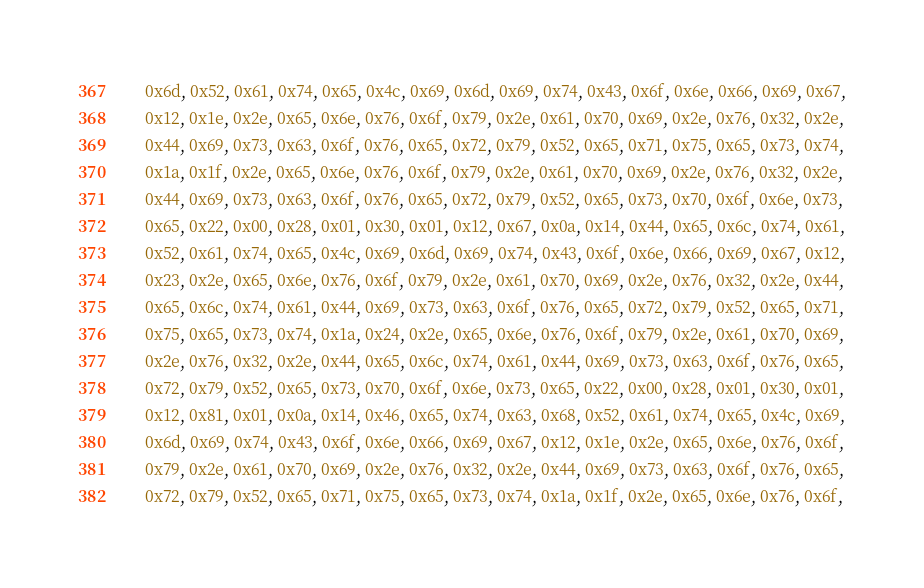Convert code to text. <code><loc_0><loc_0><loc_500><loc_500><_Go_>	0x6d, 0x52, 0x61, 0x74, 0x65, 0x4c, 0x69, 0x6d, 0x69, 0x74, 0x43, 0x6f, 0x6e, 0x66, 0x69, 0x67,
	0x12, 0x1e, 0x2e, 0x65, 0x6e, 0x76, 0x6f, 0x79, 0x2e, 0x61, 0x70, 0x69, 0x2e, 0x76, 0x32, 0x2e,
	0x44, 0x69, 0x73, 0x63, 0x6f, 0x76, 0x65, 0x72, 0x79, 0x52, 0x65, 0x71, 0x75, 0x65, 0x73, 0x74,
	0x1a, 0x1f, 0x2e, 0x65, 0x6e, 0x76, 0x6f, 0x79, 0x2e, 0x61, 0x70, 0x69, 0x2e, 0x76, 0x32, 0x2e,
	0x44, 0x69, 0x73, 0x63, 0x6f, 0x76, 0x65, 0x72, 0x79, 0x52, 0x65, 0x73, 0x70, 0x6f, 0x6e, 0x73,
	0x65, 0x22, 0x00, 0x28, 0x01, 0x30, 0x01, 0x12, 0x67, 0x0a, 0x14, 0x44, 0x65, 0x6c, 0x74, 0x61,
	0x52, 0x61, 0x74, 0x65, 0x4c, 0x69, 0x6d, 0x69, 0x74, 0x43, 0x6f, 0x6e, 0x66, 0x69, 0x67, 0x12,
	0x23, 0x2e, 0x65, 0x6e, 0x76, 0x6f, 0x79, 0x2e, 0x61, 0x70, 0x69, 0x2e, 0x76, 0x32, 0x2e, 0x44,
	0x65, 0x6c, 0x74, 0x61, 0x44, 0x69, 0x73, 0x63, 0x6f, 0x76, 0x65, 0x72, 0x79, 0x52, 0x65, 0x71,
	0x75, 0x65, 0x73, 0x74, 0x1a, 0x24, 0x2e, 0x65, 0x6e, 0x76, 0x6f, 0x79, 0x2e, 0x61, 0x70, 0x69,
	0x2e, 0x76, 0x32, 0x2e, 0x44, 0x65, 0x6c, 0x74, 0x61, 0x44, 0x69, 0x73, 0x63, 0x6f, 0x76, 0x65,
	0x72, 0x79, 0x52, 0x65, 0x73, 0x70, 0x6f, 0x6e, 0x73, 0x65, 0x22, 0x00, 0x28, 0x01, 0x30, 0x01,
	0x12, 0x81, 0x01, 0x0a, 0x14, 0x46, 0x65, 0x74, 0x63, 0x68, 0x52, 0x61, 0x74, 0x65, 0x4c, 0x69,
	0x6d, 0x69, 0x74, 0x43, 0x6f, 0x6e, 0x66, 0x69, 0x67, 0x12, 0x1e, 0x2e, 0x65, 0x6e, 0x76, 0x6f,
	0x79, 0x2e, 0x61, 0x70, 0x69, 0x2e, 0x76, 0x32, 0x2e, 0x44, 0x69, 0x73, 0x63, 0x6f, 0x76, 0x65,
	0x72, 0x79, 0x52, 0x65, 0x71, 0x75, 0x65, 0x73, 0x74, 0x1a, 0x1f, 0x2e, 0x65, 0x6e, 0x76, 0x6f,</code> 